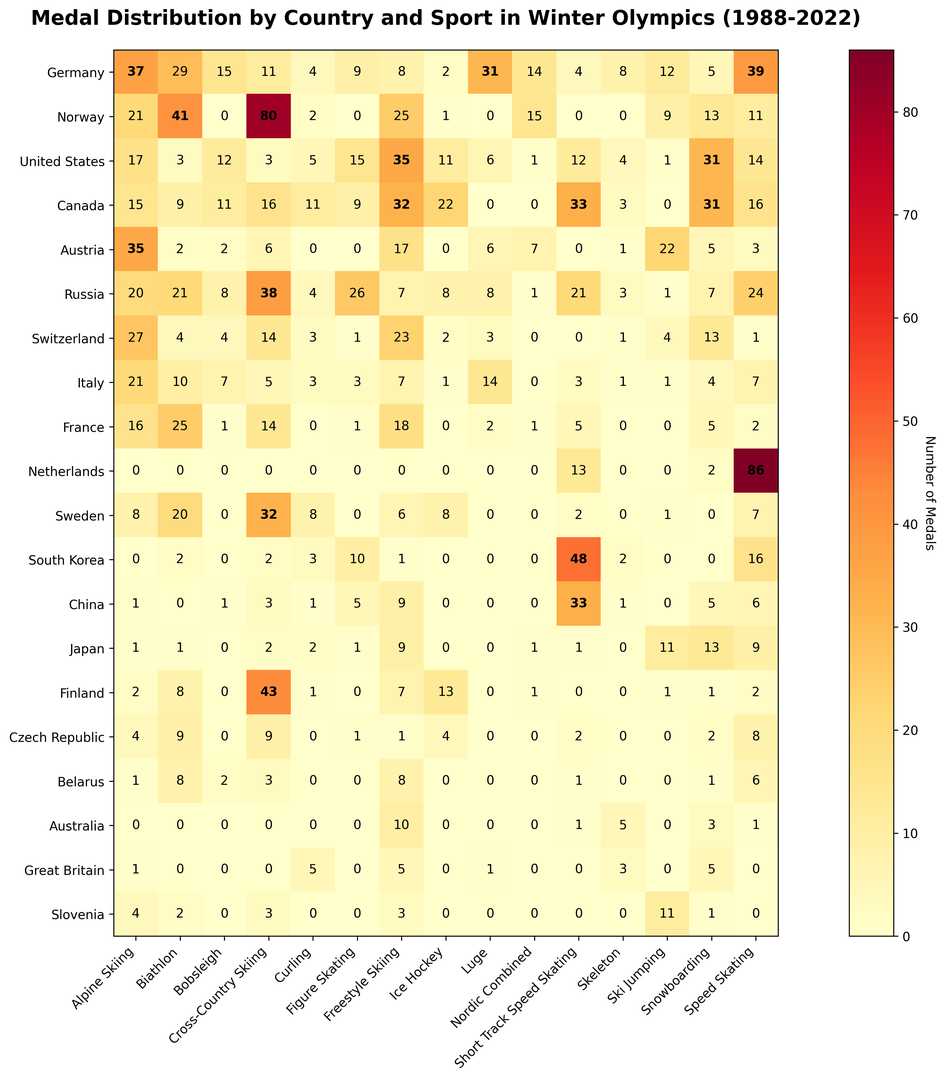Which country has won the most medals in Speed Skating? First, identify the column for Speed Skating and observe the values for each country. The highest value in the Speed Skating column will indicate the country with the most medals. Netherlands has the highest number of medals in Speed Skating with 86.
Answer: Netherlands Which sport did Norway win the most medals in? Look at the row for Norway and identify the highest value in that row, which represents the number of medals won in a particular sport. Norway has won the most medals in Cross-Country Skiing with 80 medals.
Answer: Cross-Country Skiing How many medals has the United States won in total across Biathlon and Bobsleigh? Find the values for the United States in the Biathlon and Bobsleigh columns and sum them up. The United States won 3 medals in Biathlon and 12 in Bobsleigh, so 3 + 12 = 15.
Answer: 15 Which sports have Germany won more than 30 medals in? For Germany, observe each value on the heatmap and identify the sports where the value exceeds 30. Germany has won more than 30 medals in Alpine Skiing (37), Luge (31), and Speed Skating (39).
Answer: Alpine Skiing, Luge, Speed Skating Compare the medal counts of United States and Canada in Ice Hockey. Which country has more medals? Look at the values in the Ice Hockey column for both the United States and Canada. The United States has 11 medals, while Canada has 22. Therefore, Canada has more medals.
Answer: Canada Which country has won the least number of medals in Short Track Speed Skating? Identify the values in the Short Track Speed Skating column and find the minimum value. Multiple countries may have 0 medals, but among non-zero values, Great Britain and Slovenia with 0 medals have the least.
Answer: Great Britain and Slovenia Which country has the highest combined medal count in Alpine Skiing and Nordic Combined? Sum the medal values for each country in the Alpine Skiing and Nordic Combined columns and compare the total values. For example, Germany has 37 (Alpine Skiing) + 14 (Nordic Combined) = 51. Perform this for all countries. Norway has the highest combined total of 21 (Alpine Skiing) + 15 (Nordic Combined) = 36.
Answer: Norway What is the highest number of medals won by any country in a single sport, and which sport is it? Scan the heatmap for the highest individual value and identify the corresponding sport and country. The highest number of medals in a single sport is 86, won by the Netherlands in Speed Skating.
Answer: 86, Speed Skating How many more medals did Russia win in Figure Skating than Germany? Find the medal counts for Russia and Germany in Figure Skating and calculate the difference. Russia has 26 medals and Germany has 9, so 26 - 9 = 17.
Answer: 17 Which country has the highest diversity in winning medals across different sports, judging by the number of different sports they have won medals in? Count the number of non-zero entries for each country across all sports and compare. The country with the highest number of non-zero entries indicates the highest diversity. Germany and Norway, with medals in 11 different sports, have the highest diversity.
Answer: Germany, Norway 